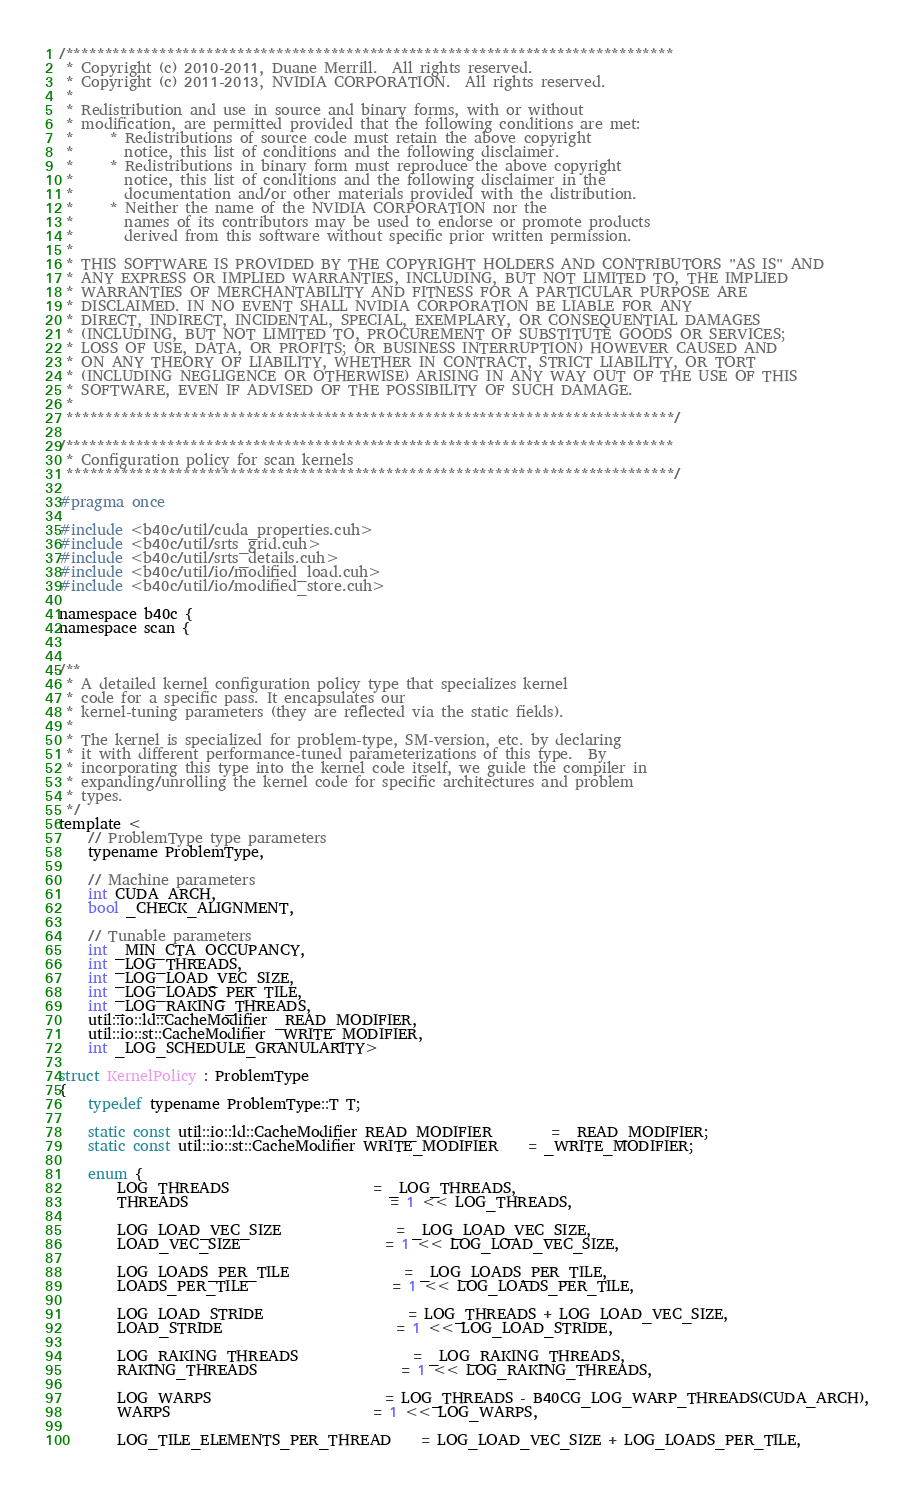<code> <loc_0><loc_0><loc_500><loc_500><_Cuda_>/******************************************************************************
 * Copyright (c) 2010-2011, Duane Merrill.  All rights reserved.
 * Copyright (c) 2011-2013, NVIDIA CORPORATION.  All rights reserved.
 * 
 * Redistribution and use in source and binary forms, with or without
 * modification, are permitted provided that the following conditions are met:
 *     * Redistributions of source code must retain the above copyright
 *       notice, this list of conditions and the following disclaimer.
 *     * Redistributions in binary form must reproduce the above copyright
 *       notice, this list of conditions and the following disclaimer in the
 *       documentation and/or other materials provided with the distribution.
 *     * Neither the name of the NVIDIA CORPORATION nor the
 *       names of its contributors may be used to endorse or promote products
 *       derived from this software without specific prior written permission.
 * 
 * THIS SOFTWARE IS PROVIDED BY THE COPYRIGHT HOLDERS AND CONTRIBUTORS "AS IS" AND
 * ANY EXPRESS OR IMPLIED WARRANTIES, INCLUDING, BUT NOT LIMITED TO, THE IMPLIED
 * WARRANTIES OF MERCHANTABILITY AND FITNESS FOR A PARTICULAR PURPOSE ARE
 * DISCLAIMED. IN NO EVENT SHALL NVIDIA CORPORATION BE LIABLE FOR ANY
 * DIRECT, INDIRECT, INCIDENTAL, SPECIAL, EXEMPLARY, OR CONSEQUENTIAL DAMAGES
 * (INCLUDING, BUT NOT LIMITED TO, PROCUREMENT OF SUBSTITUTE GOODS OR SERVICES;
 * LOSS OF USE, DATA, OR PROFITS; OR BUSINESS INTERRUPTION) HOWEVER CAUSED AND
 * ON ANY THEORY OF LIABILITY, WHETHER IN CONTRACT, STRICT LIABILITY, OR TORT
 * (INCLUDING NEGLIGENCE OR OTHERWISE) ARISING IN ANY WAY OUT OF THE USE OF THIS
 * SOFTWARE, EVEN IF ADVISED OF THE POSSIBILITY OF SUCH DAMAGE.
 *
 ******************************************************************************/

/******************************************************************************
 * Configuration policy for scan kernels
 ******************************************************************************/

#pragma once

#include <b40c/util/cuda_properties.cuh>
#include <b40c/util/srts_grid.cuh>
#include <b40c/util/srts_details.cuh>
#include <b40c/util/io/modified_load.cuh>
#include <b40c/util/io/modified_store.cuh>

namespace b40c {
namespace scan {


/**
 * A detailed kernel configuration policy type that specializes kernel
 * code for a specific pass. It encapsulates our
 * kernel-tuning parameters (they are reflected via the static fields).
 *
 * The kernel is specialized for problem-type, SM-version, etc. by declaring
 * it with different performance-tuned parameterizations of this type.  By
 * incorporating this type into the kernel code itself, we guide the compiler in
 * expanding/unrolling the kernel code for specific architectures and problem
 * types.
 */
template <
	// ProblemType type parameters
	typename ProblemType,

	// Machine parameters
	int CUDA_ARCH,
	bool _CHECK_ALIGNMENT,

	// Tunable parameters
	int _MIN_CTA_OCCUPANCY,
	int _LOG_THREADS,
	int _LOG_LOAD_VEC_SIZE,
	int _LOG_LOADS_PER_TILE,
	int _LOG_RAKING_THREADS,
	util::io::ld::CacheModifier _READ_MODIFIER,
	util::io::st::CacheModifier _WRITE_MODIFIER,
	int _LOG_SCHEDULE_GRANULARITY>

struct KernelPolicy : ProblemType
{
	typedef typename ProblemType::T T;

	static const util::io::ld::CacheModifier READ_MODIFIER 		= _READ_MODIFIER;
	static const util::io::st::CacheModifier WRITE_MODIFIER 	= _WRITE_MODIFIER;

	enum {
		LOG_THREADS 					= _LOG_THREADS,
		THREADS							= 1 << LOG_THREADS,

		LOG_LOAD_VEC_SIZE  				= _LOG_LOAD_VEC_SIZE,
		LOAD_VEC_SIZE					= 1 << LOG_LOAD_VEC_SIZE,

		LOG_LOADS_PER_TILE 				= _LOG_LOADS_PER_TILE,
		LOADS_PER_TILE					= 1 << LOG_LOADS_PER_TILE,

		LOG_LOAD_STRIDE					= LOG_THREADS + LOG_LOAD_VEC_SIZE,
		LOAD_STRIDE						= 1 << LOG_LOAD_STRIDE,

		LOG_RAKING_THREADS				= _LOG_RAKING_THREADS,
		RAKING_THREADS					= 1 << LOG_RAKING_THREADS,

		LOG_WARPS						= LOG_THREADS - B40CG_LOG_WARP_THREADS(CUDA_ARCH),
		WARPS							= 1 << LOG_WARPS,

		LOG_TILE_ELEMENTS_PER_THREAD	= LOG_LOAD_VEC_SIZE + LOG_LOADS_PER_TILE,</code> 